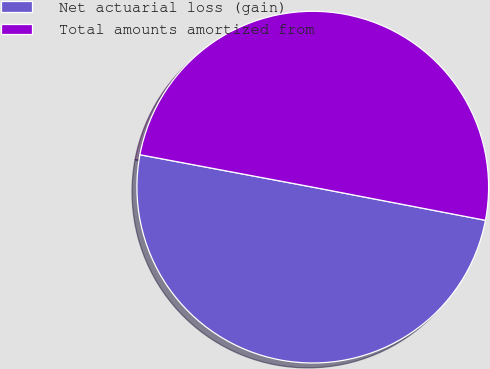Convert chart. <chart><loc_0><loc_0><loc_500><loc_500><pie_chart><fcel>Net actuarial loss (gain)<fcel>Total amounts amortized from<nl><fcel>49.93%<fcel>50.07%<nl></chart> 